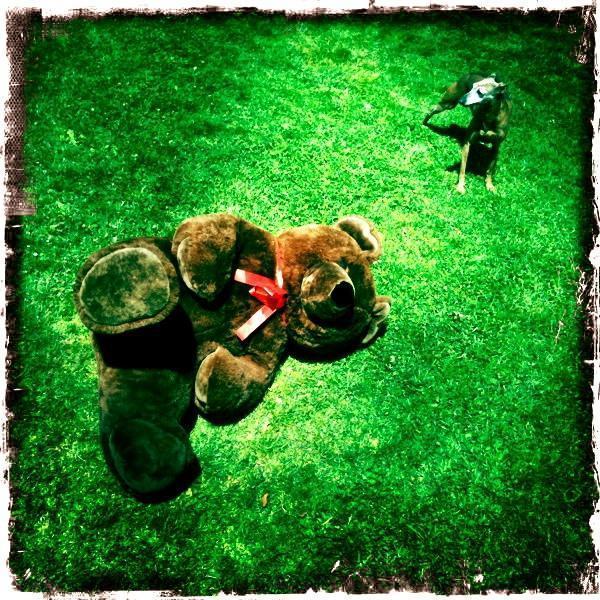How many teddy bears are visible?
Give a very brief answer. 3. 